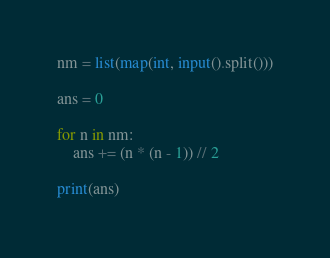<code> <loc_0><loc_0><loc_500><loc_500><_Python_>nm = list(map(int, input().split()))

ans = 0

for n in nm:
    ans += (n * (n - 1)) // 2

print(ans)
</code> 